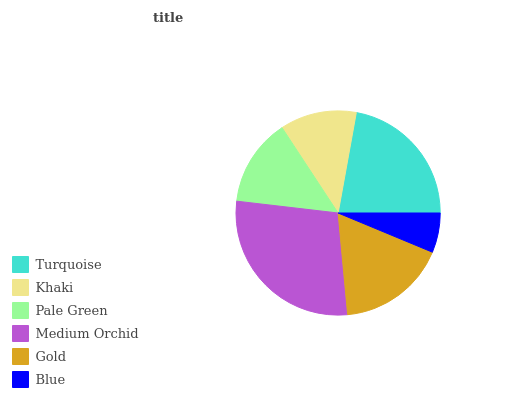Is Blue the minimum?
Answer yes or no. Yes. Is Medium Orchid the maximum?
Answer yes or no. Yes. Is Khaki the minimum?
Answer yes or no. No. Is Khaki the maximum?
Answer yes or no. No. Is Turquoise greater than Khaki?
Answer yes or no. Yes. Is Khaki less than Turquoise?
Answer yes or no. Yes. Is Khaki greater than Turquoise?
Answer yes or no. No. Is Turquoise less than Khaki?
Answer yes or no. No. Is Gold the high median?
Answer yes or no. Yes. Is Pale Green the low median?
Answer yes or no. Yes. Is Medium Orchid the high median?
Answer yes or no. No. Is Blue the low median?
Answer yes or no. No. 